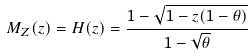Convert formula to latex. <formula><loc_0><loc_0><loc_500><loc_500>M _ { Z } ( z ) = H ( z ) = \frac { 1 - \sqrt { 1 - z ( 1 - \theta ) } } { 1 - \sqrt { \theta } }</formula> 